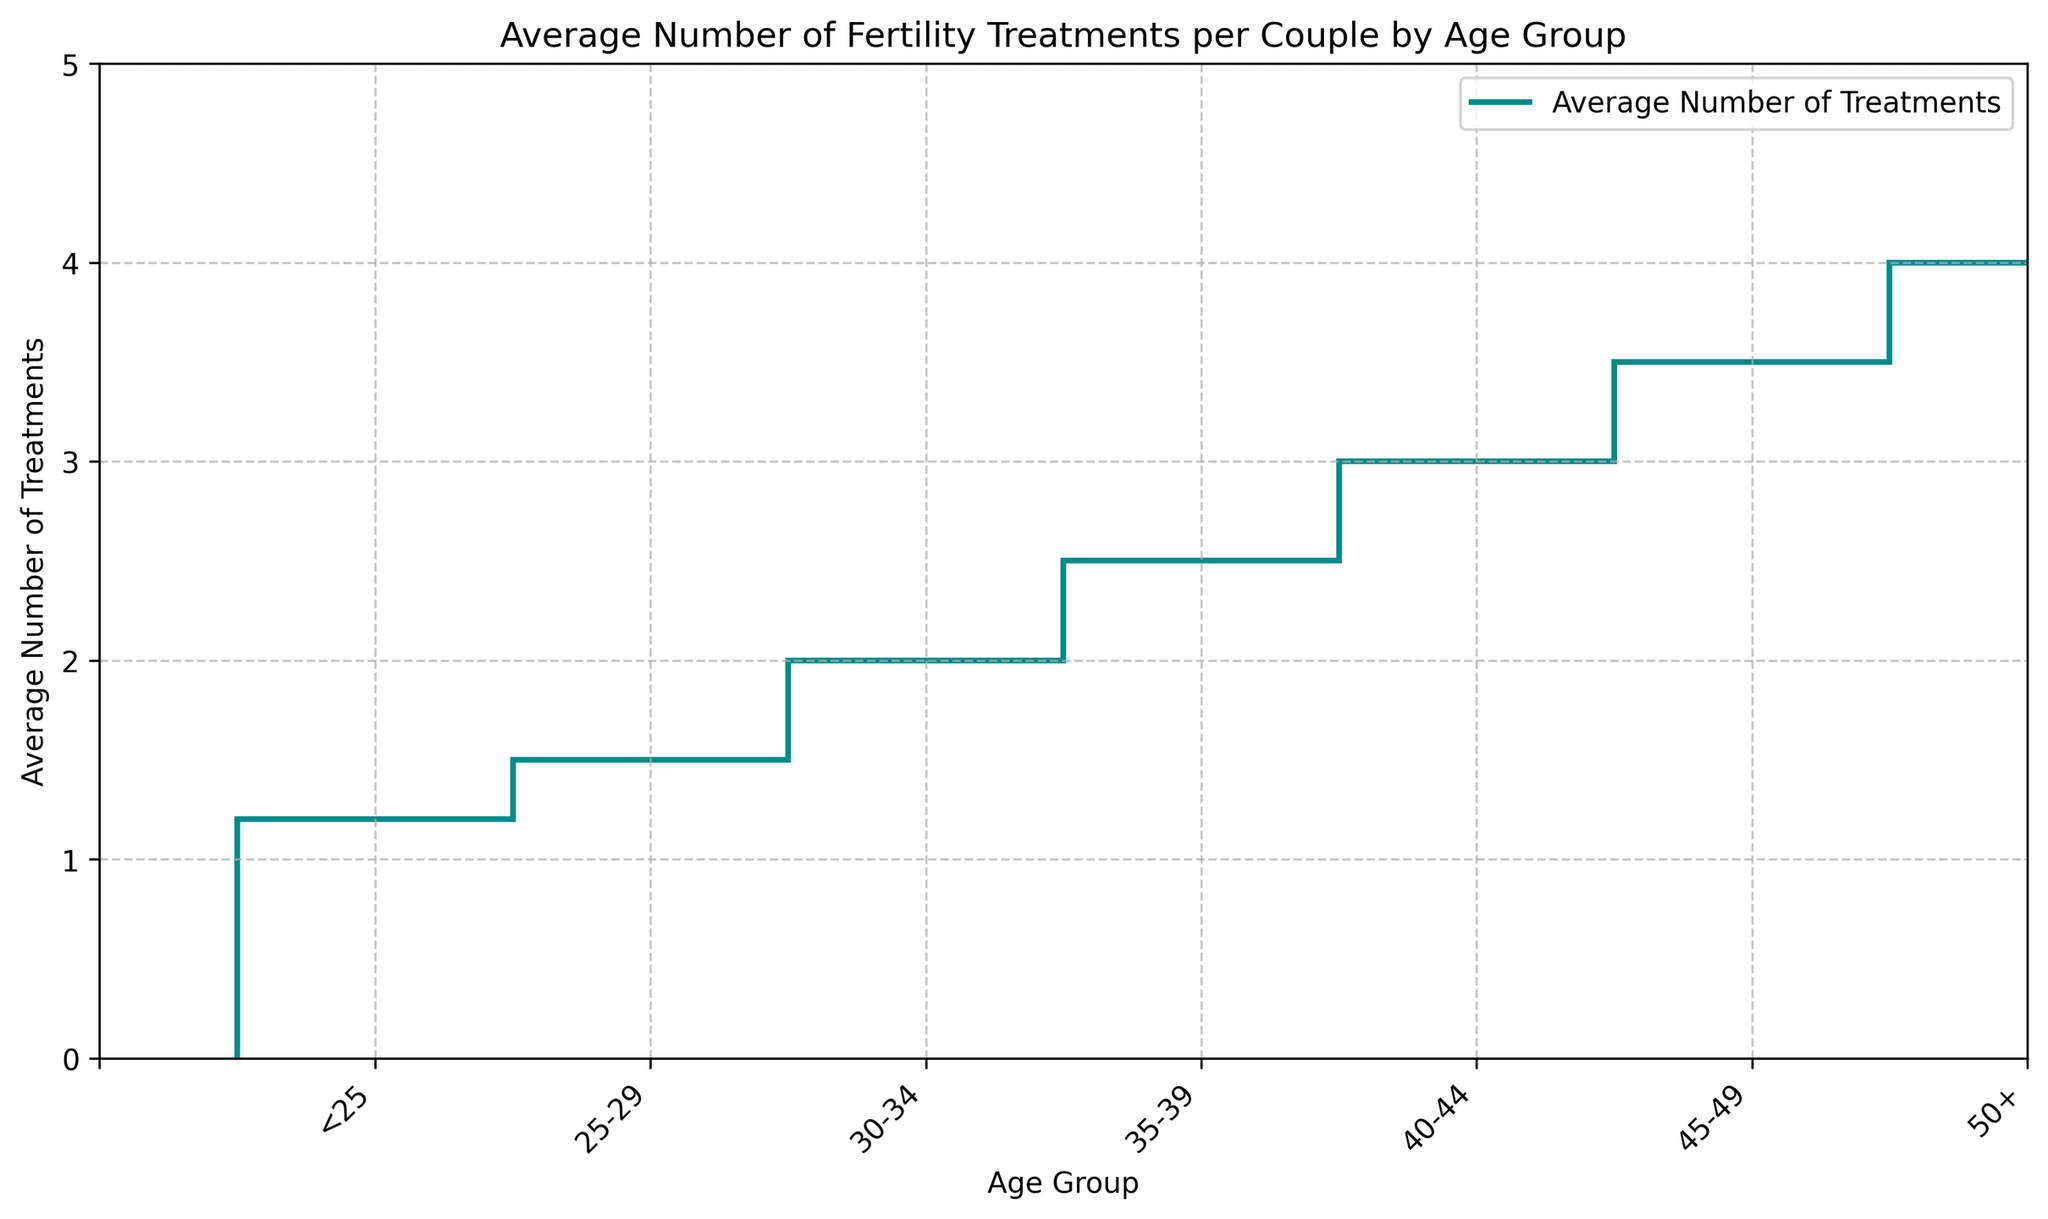What's the average number of treatments for couples aged 35-39? To find the average number of treatments for couples aged 35-39, refer to the data point labeled '35-39' on the x-axis. The corresponding value is 2.5.
Answer: 2.5 How does the average number of treatments for couples aged 40-44 compare to those over 50? Look at the values corresponding to '40-44' and '50+' on the x-axis. The average number of treatments for '40-44' is 3.0, and for '50+' it is 4.0. Comparing these, 4.0 is greater than 3.0.
Answer: 4.0 is greater What is the increase in the average number of treatments from the age group 25-29 to 30-34? Determine the values for '25-29' and '30-34', which are 1.5 and 2.0, respectively. The increase is calculated by subtracting 1.5 from 2.0, resulting in 0.5.
Answer: 0.5 Which age group has the highest average number of treatments? Examine all the data points on the plot and identify the highest value. The age group '50+' has the highest value, which is 4.0.
Answer: 50+ What is the total number of treatments for the age groups <25 and 25-29 combined? Add the average number of treatments for '<25' and '25-29', which are 1.2 and 1.5, respectively. The total is 1.2 + 1.5 = 2.7.
Answer: 2.7 Are there any age groups with the same average number of treatments? Examine the data points on the plot; each age group has a distinct average number of treatments, so no age groups share the same value.
Answer: No What is the difference in the average number of treatments between couples aged 30-34 and those aged 45-49? Find the values for '30-34' and '45-49,' which are 2.0 and 3.5, respectively. Subtract 2.0 from 3.5 to get 1.5.
Answer: 1.5 How much higher is the average number of treatments for couples aged 50+ compared to those aged 35-39? The value for '50+' is 4.0 and for '35-39' is 2.5. Subtracting 2.5 from 4.0 gives 1.5.
Answer: 1.5 What age group shows an average number of treatments that is closest to 3.0? Identify the age group with an average number of treatments closest to 3.0. The age group '40-44' has an average number of treatments exactly equal to 3.0.
Answer: 40-44 What is the overall trend in the average number of treatments as age increases? Observe the plot's progression from left to right: the average number of treatments consistently increases with age, showing an upward trend.
Answer: Increases 